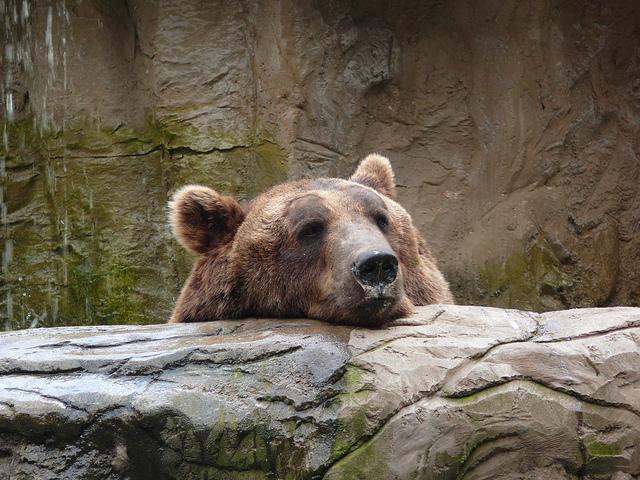Are the bear's legs visible in this photograph?
Answer briefly. No. Is the habitat natural?
Write a very short answer. No. What is this animal?
Give a very brief answer. Bear. 